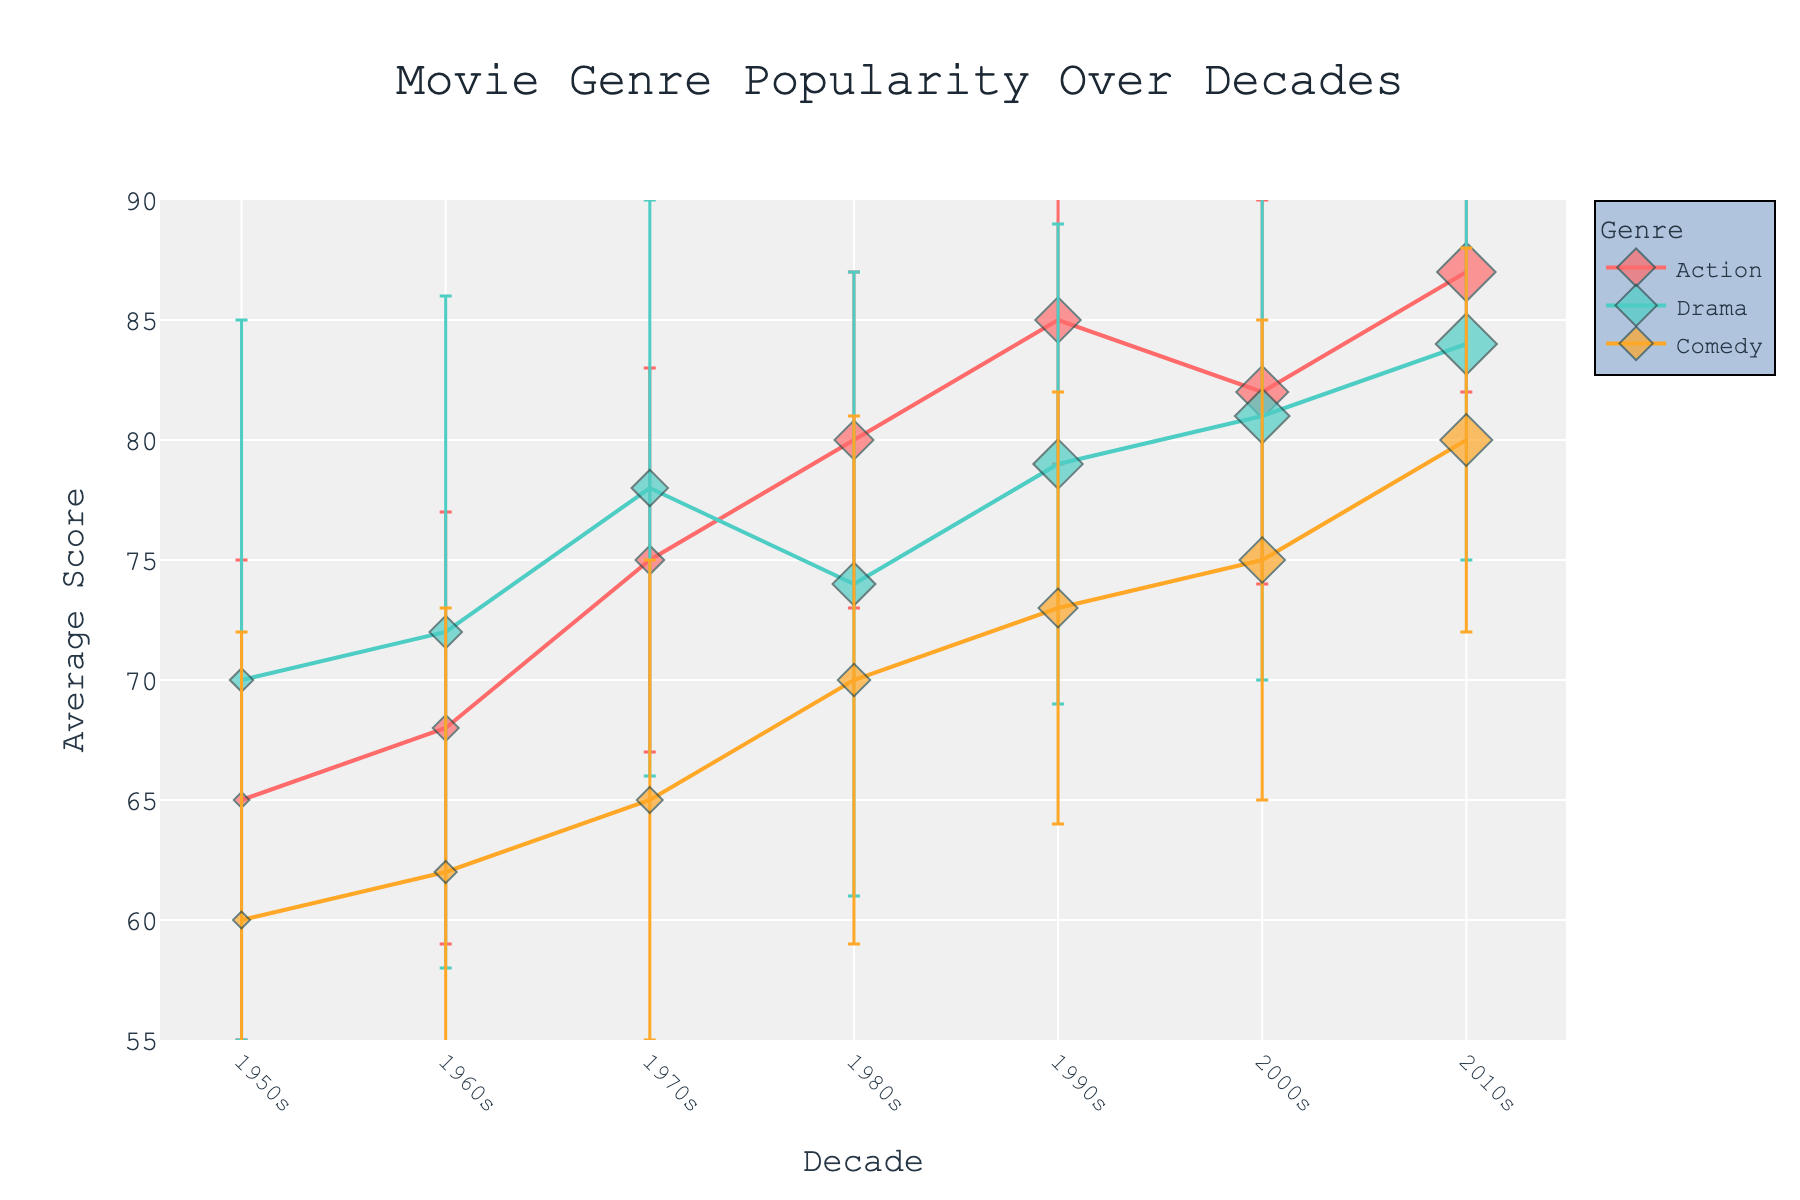How many genres are displayed in the plot? The plot has three distinct lines and markers, each with a different color and label representing a genre. By inspecting the legend, we see that the genres are Action, Drama, and Comedy.
Answer: Three What is the title of the plot? The title of the plot is positioned at the top center and clearly written as "Movie Genre Popularity Over Decades."
Answer: Movie Genre Popularity Over Decades Which genre has the highest average score in the 2010s? To determine this, look at the data points for each genre (Action, Drama, Comedy) in the 2010s on the x-axis. By comparing the y-values (average scores), Action has the highest average score at 87.
Answer: Action What is the average score of Comedy in the 2000s? Find the data point for Comedy in the 2000s on the x-axis. The corresponding y-value indicates the average score. For Comedy in the 2000s, the score is 75.
Answer: 75 How many movies were released in the Action genre in the 1990s? Look at the size of the marker for Action in the 1990s. The size of each marker is proportional to the number of movies released. The marker size relative to the legend indicates 35 movies.
Answer: 35 Which genre shows a smaller variation in critical scores in the 1970s? Variation in critical scores can be inferred from the length of the error bars. The genre with shorter error bars indicates smaller standard deviation. In the 1970s, Action has shorter error bars than Drama and Comedy.
Answer: Action What is the difference in average score between Action and Drama in the 1980s? Locate the points for Action and Drama in the 1980s. Action has an average score of 80, and Drama has an average score of 74. The difference is 80 - 74.
Answer: 6 Which decade saw the most significant increase in average score for the Action genre? Observe the trend line for Action across decades. Calculate the difference between consecutive decades. The most significant jump is between the 1990s (85) and 2010s (87), a 2-point increase.
Answer: 2 Which genre had the lowest average score in the 1950s? Compare the data points for each genre (Action, Drama, Comedy) in the 1950s. Comedy, with an average score of 60, has the lowest score among them.
Answer: Comedy Which genre shows the most consistent average scores over the decades? Consistency can be assessed by looking at the variation in y-values over decades. Drama, with its relatively steady changes, appears to be the most consistent.
Answer: Drama 